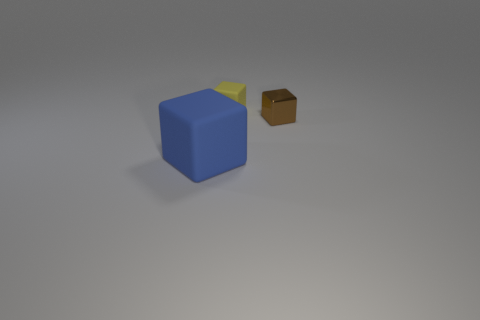What is the tiny object that is to the left of the brown block made of?
Keep it short and to the point. Rubber. Is the block in front of the small metal object made of the same material as the brown thing?
Your response must be concise. No. The blue object that is the same shape as the yellow rubber object is what size?
Provide a short and direct response. Large. There is a matte object that is behind the tiny brown block; is its color the same as the object that is in front of the brown metallic thing?
Your response must be concise. No. What number of other things are there of the same color as the large object?
Your response must be concise. 0. What color is the small thing that is on the right side of the matte block to the right of the rubber cube in front of the small brown metal block?
Your answer should be compact. Brown. Is the number of metallic objects to the right of the brown block the same as the number of tiny cubes?
Give a very brief answer. No. Is the size of the cube behind the brown metallic object the same as the big matte cube?
Your answer should be very brief. No. How many tiny cyan rubber balls are there?
Provide a succinct answer. 0. What number of blocks are both behind the big blue matte object and to the left of the tiny brown metallic cube?
Provide a short and direct response. 1. 